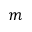Convert formula to latex. <formula><loc_0><loc_0><loc_500><loc_500>m</formula> 